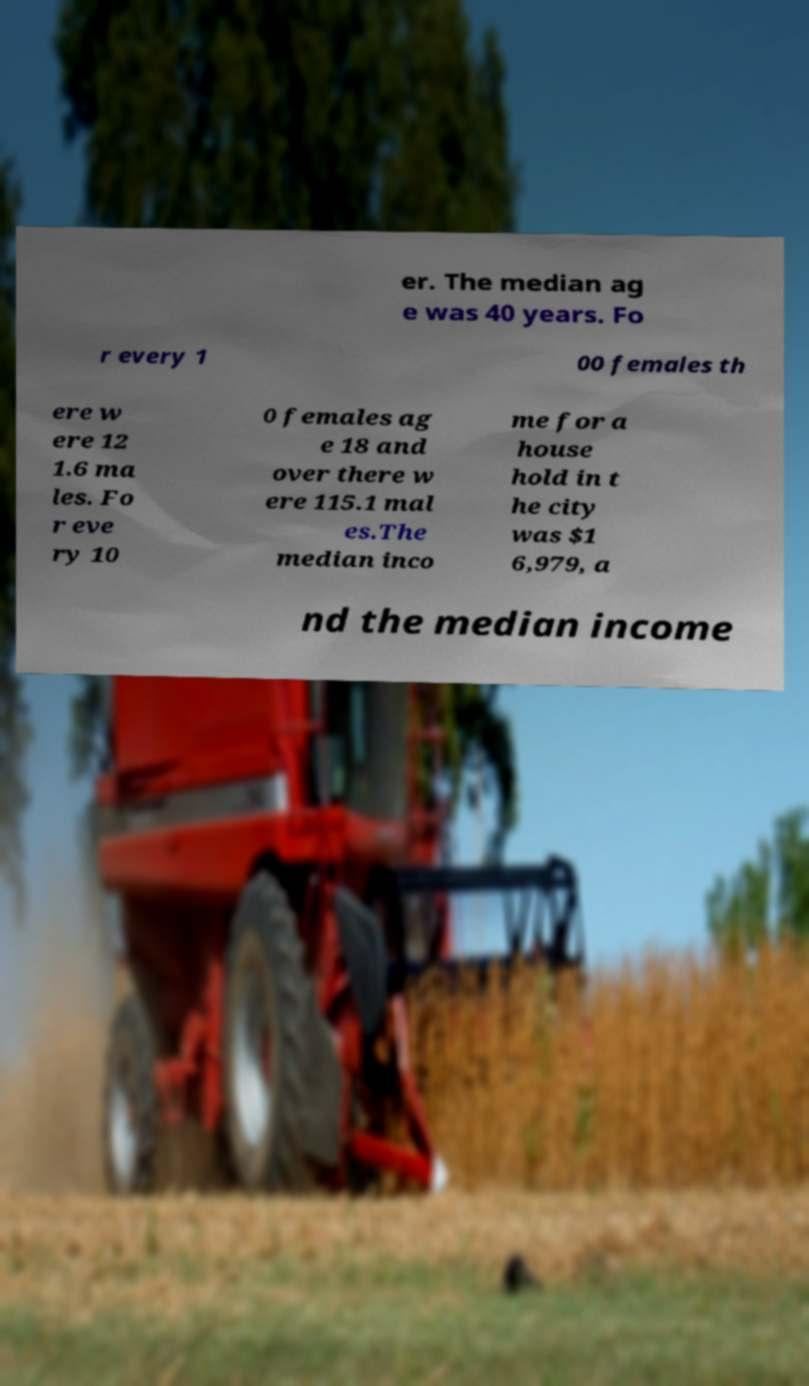Can you accurately transcribe the text from the provided image for me? er. The median ag e was 40 years. Fo r every 1 00 females th ere w ere 12 1.6 ma les. Fo r eve ry 10 0 females ag e 18 and over there w ere 115.1 mal es.The median inco me for a house hold in t he city was $1 6,979, a nd the median income 